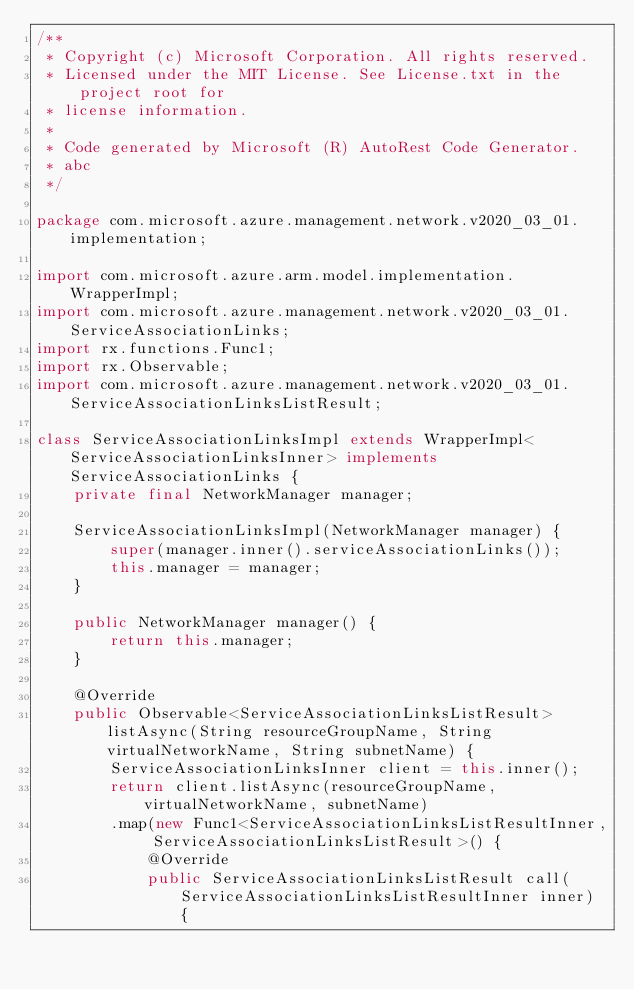<code> <loc_0><loc_0><loc_500><loc_500><_Java_>/**
 * Copyright (c) Microsoft Corporation. All rights reserved.
 * Licensed under the MIT License. See License.txt in the project root for
 * license information.
 *
 * Code generated by Microsoft (R) AutoRest Code Generator.
 * abc
 */

package com.microsoft.azure.management.network.v2020_03_01.implementation;

import com.microsoft.azure.arm.model.implementation.WrapperImpl;
import com.microsoft.azure.management.network.v2020_03_01.ServiceAssociationLinks;
import rx.functions.Func1;
import rx.Observable;
import com.microsoft.azure.management.network.v2020_03_01.ServiceAssociationLinksListResult;

class ServiceAssociationLinksImpl extends WrapperImpl<ServiceAssociationLinksInner> implements ServiceAssociationLinks {
    private final NetworkManager manager;

    ServiceAssociationLinksImpl(NetworkManager manager) {
        super(manager.inner().serviceAssociationLinks());
        this.manager = manager;
    }

    public NetworkManager manager() {
        return this.manager;
    }

    @Override
    public Observable<ServiceAssociationLinksListResult> listAsync(String resourceGroupName, String virtualNetworkName, String subnetName) {
        ServiceAssociationLinksInner client = this.inner();
        return client.listAsync(resourceGroupName, virtualNetworkName, subnetName)
        .map(new Func1<ServiceAssociationLinksListResultInner, ServiceAssociationLinksListResult>() {
            @Override
            public ServiceAssociationLinksListResult call(ServiceAssociationLinksListResultInner inner) {</code> 